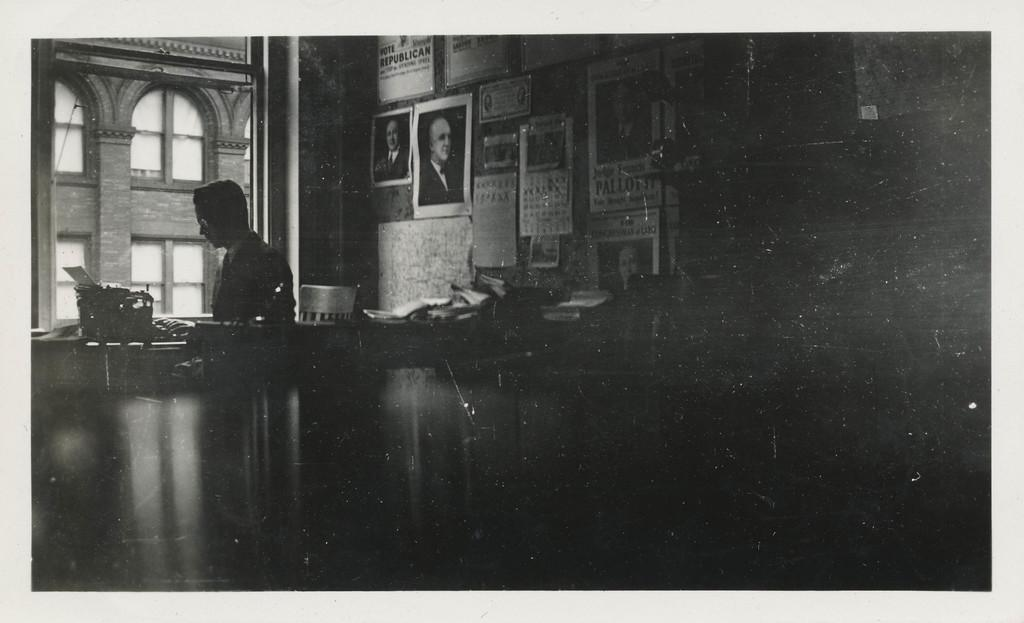What is on the wall in the image? There are posters on the wall in the image. What is the person in the image doing? The person is sitting on a chair in the image. What is in front of the person? There is an object in front of the person. What can be seen beside the person? There is a window beside the person. How many hens are visible in the image? There are no hens present in the image. What type of dogs can be seen playing with the person in the image? There are no dogs present in the image. Is the person in the image a boy? The gender of the person in the image cannot be determined from the provided facts. 